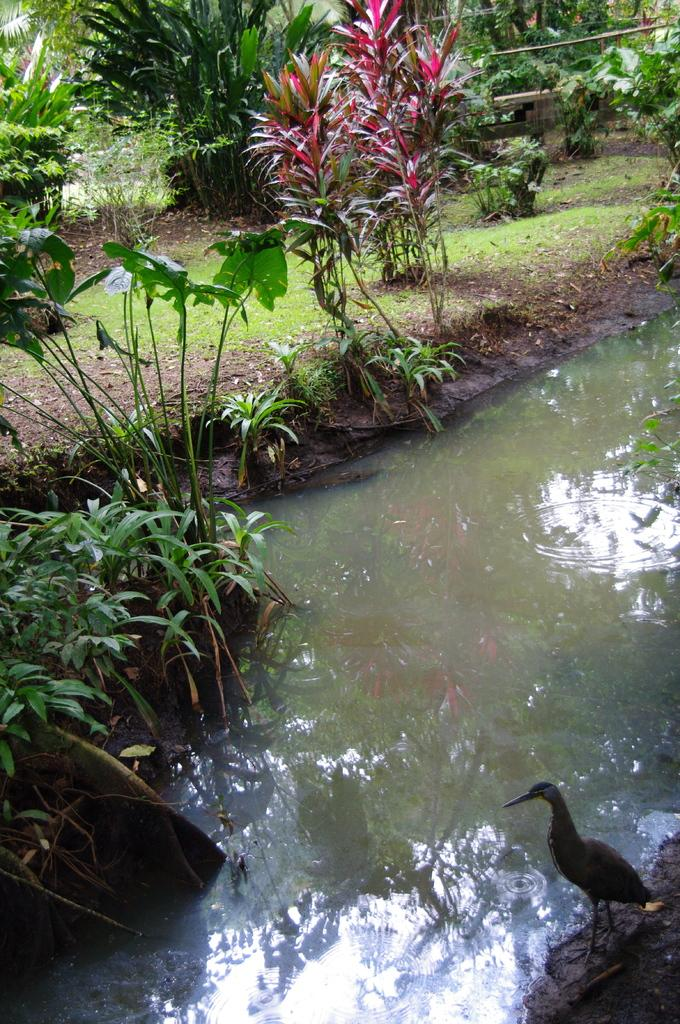What type of vegetation is present in the image? There are many plants and trees in the image. Where are the plants and trees located? The plants and trees are on a grassland. What other feature can be seen in the image? There is a canal in the image. Can you describe the bird in the image? A bird is standing on the right side of the image. What type of string is being used by the plants to grow in the image? There is no string present in the image; the plants are growing naturally on the grassland. 